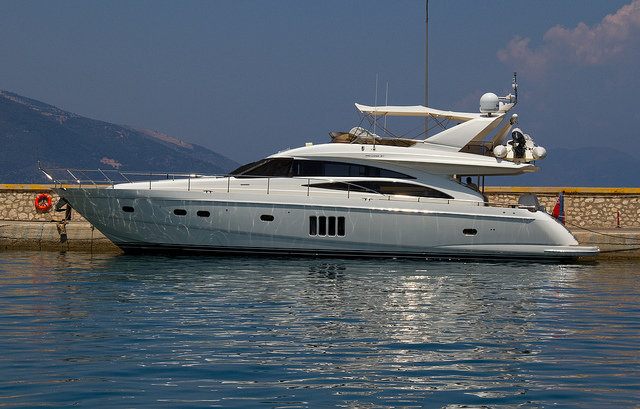<image>What mountain is in the background? I am not sure what mountain is in the background. It could be Everest, Vesuvio, Mount St Helens, Diamond Head, Tamalpais or Alps. What harbor is the boat in? It is ambiguous what harbor the boat is in. It could be pearl, miami, sydney, greek, france, or man made. What harbor is the boat in? I don't know in what harbor the boat is. It could be in Pearl Harbor, Miami Harbor, Sydney Harbor, or any other harbor mentioned. What mountain is in the background? I am not aware of the mountain in the background. It can be either 'everest', 'mount st helens', 'vesuvio', 'diamond head', 'tamalpais', or 'alps'. 